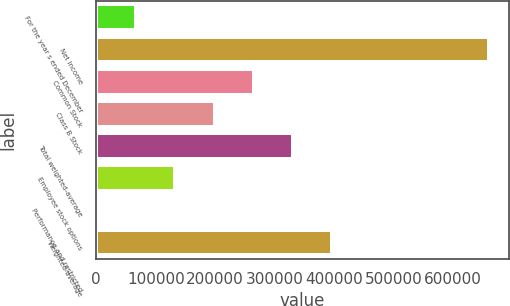<chart> <loc_0><loc_0><loc_500><loc_500><bar_chart><fcel>For the year s ended December<fcel>Net income<fcel>Common Stock<fcel>Class B Stock<fcel>Total weighted-average<fcel>Employee stock options<fcel>Performance and restricted<fcel>Weighted-average<nl><fcel>66716.8<fcel>660931<fcel>264788<fcel>198764<fcel>330812<fcel>132741<fcel>693<fcel>396836<nl></chart> 